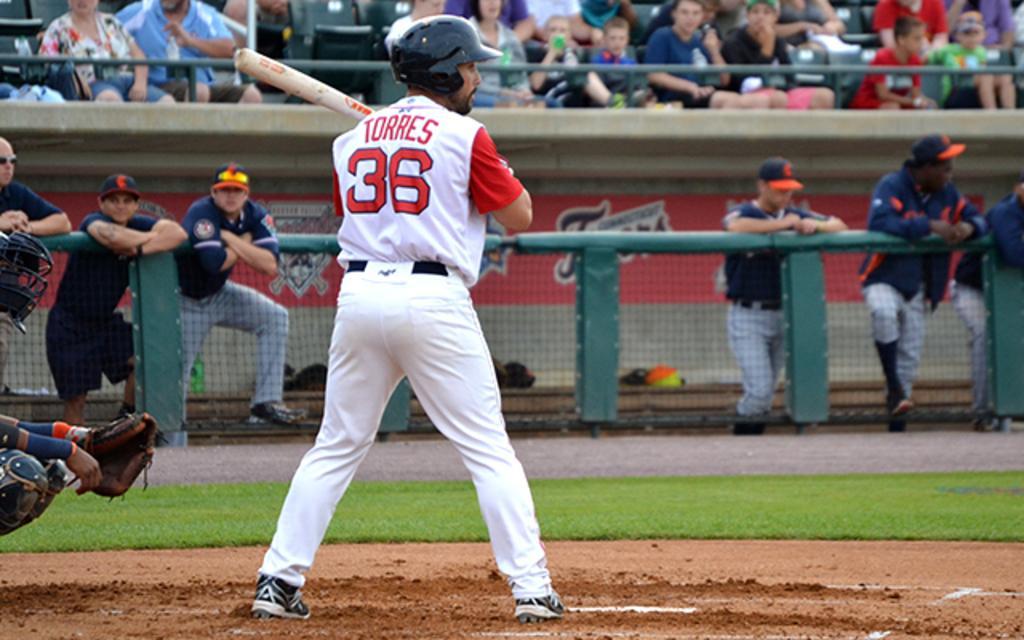Can you describe this image briefly? In this picture there is a man who is wearing thirty six number jersey, trouser and show. He is holding a base-bat. At the backside of him we can see the wicket-keeper who is wearing helmet, gloves and trouser. On the right there are three persons were standing near to the fencing. On the left we can see another three persons were standing near to the bench. On the bench we can see the bags and helmets. At the top we can see the audience were watching the game and sitting on the chair. 